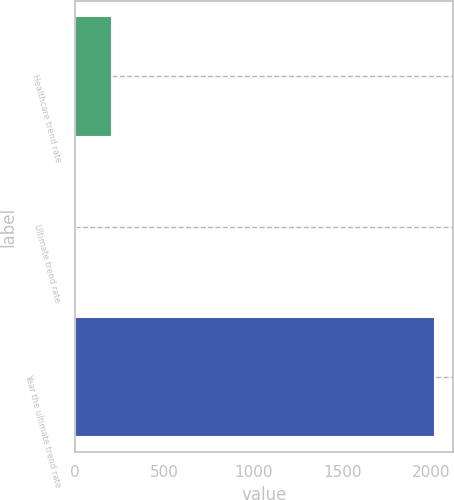Convert chart. <chart><loc_0><loc_0><loc_500><loc_500><bar_chart><fcel>Healthcare trend rate<fcel>Ultimate trend rate<fcel>Year the ultimate trend rate<nl><fcel>206.4<fcel>5<fcel>2019<nl></chart> 